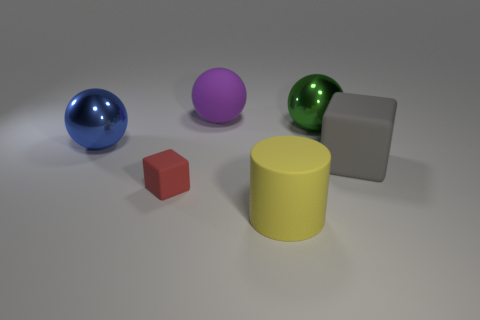There is a big matte thing right of the shiny ball that is behind the large blue object; what is its shape?
Give a very brief answer. Cube. Are there an equal number of green balls that are left of the large block and blue spheres?
Offer a very short reply. Yes. What is the cube on the left side of the rubber thing that is behind the big sphere that is left of the red rubber object made of?
Keep it short and to the point. Rubber. Are there any green shiny spheres that have the same size as the purple rubber sphere?
Ensure brevity in your answer.  Yes. What shape is the large yellow matte thing?
Your response must be concise. Cylinder. How many cylinders are gray matte objects or big yellow things?
Make the answer very short. 1. Is the number of small red matte cubes that are right of the large cube the same as the number of big blocks on the left side of the big purple rubber thing?
Offer a very short reply. Yes. What number of large purple spheres are behind the big rubber thing that is behind the shiny ball right of the large blue metal sphere?
Your answer should be compact. 0. Does the small rubber block have the same color as the matte cube behind the tiny matte block?
Provide a succinct answer. No. Are there more red things on the right side of the large yellow rubber object than large yellow rubber cylinders?
Your answer should be compact. No. 